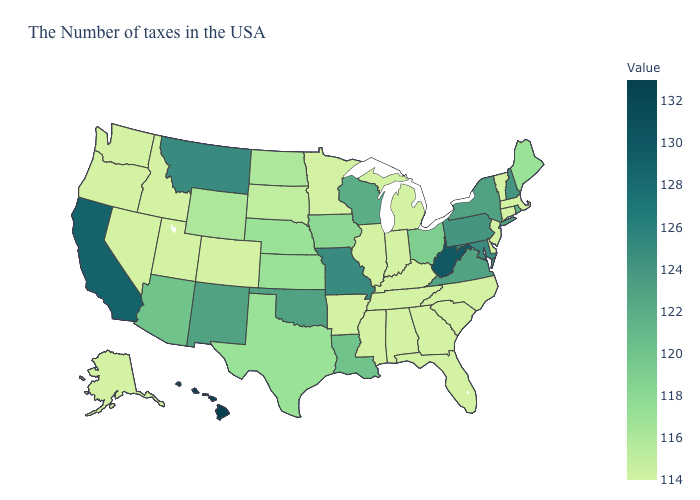Does New Hampshire have a higher value than California?
Concise answer only. No. Among the states that border New Hampshire , which have the highest value?
Short answer required. Maine. Among the states that border Illinois , does Missouri have the highest value?
Short answer required. Yes. Does Kansas have the highest value in the USA?
Quick response, please. No. Does Arizona have a higher value than Montana?
Short answer required. No. Among the states that border Illinois , does Iowa have the lowest value?
Quick response, please. No. Which states have the lowest value in the South?
Keep it brief. Delaware, North Carolina, South Carolina, Florida, Georgia, Kentucky, Alabama, Tennessee, Mississippi, Arkansas. Among the states that border Indiana , does Michigan have the lowest value?
Answer briefly. Yes. 